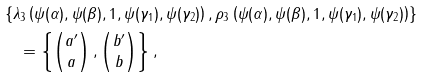Convert formula to latex. <formula><loc_0><loc_0><loc_500><loc_500>& \left \{ \lambda _ { 3 } \left ( \psi ( \alpha ) , \psi ( \beta ) , 1 , \psi ( \gamma _ { 1 } ) , \psi ( \gamma _ { 2 } ) \right ) , \rho _ { 3 } \left ( \psi ( \alpha ) , \psi ( \beta ) , 1 , \psi ( \gamma _ { 1 } ) , \psi ( \gamma _ { 2 } ) \right ) \right \} \\ & \quad = \left \{ \begin{pmatrix} a ^ { \prime } \\ a \end{pmatrix} , \begin{pmatrix} b ^ { \prime } \\ b \end{pmatrix} \right \} ,</formula> 